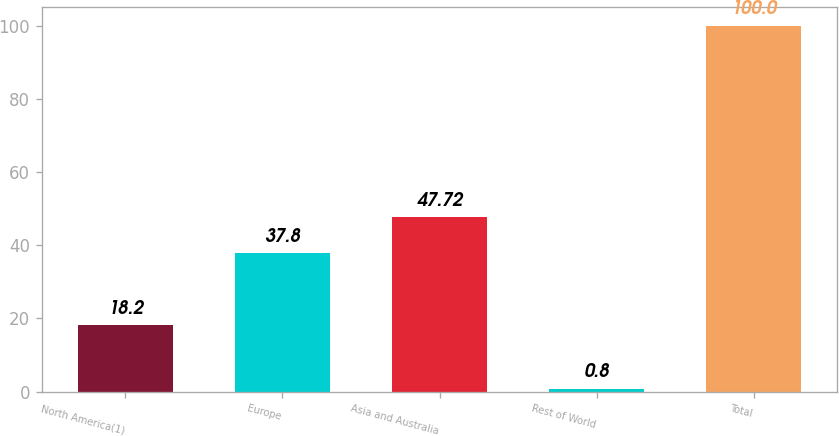Convert chart. <chart><loc_0><loc_0><loc_500><loc_500><bar_chart><fcel>North America(1)<fcel>Europe<fcel>Asia and Australia<fcel>Rest of World<fcel>Total<nl><fcel>18.2<fcel>37.8<fcel>47.72<fcel>0.8<fcel>100<nl></chart> 